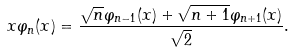Convert formula to latex. <formula><loc_0><loc_0><loc_500><loc_500>x \varphi _ { n } ( x ) = \frac { \sqrt { n } \varphi _ { n - 1 } ( x ) + \sqrt { n + 1 } \varphi _ { n + 1 } ( x ) } { \sqrt { 2 } } .</formula> 